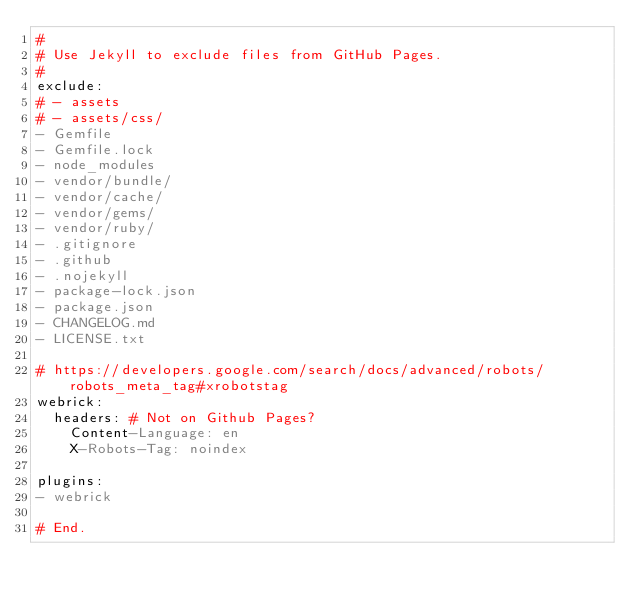<code> <loc_0><loc_0><loc_500><loc_500><_YAML_>#
# Use Jekyll to exclude files from GitHub Pages.
#
exclude:
# - assets
# - assets/css/
- Gemfile
- Gemfile.lock
- node_modules
- vendor/bundle/
- vendor/cache/
- vendor/gems/
- vendor/ruby/
- .gitignore
- .github
- .nojekyll
- package-lock.json
- package.json
- CHANGELOG.md
- LICENSE.txt

# https://developers.google.com/search/docs/advanced/robots/robots_meta_tag#xrobotstag
webrick:
  headers: # Not on Github Pages?
    Content-Language: en
    X-Robots-Tag: noindex

plugins:
- webrick

# End.
</code> 